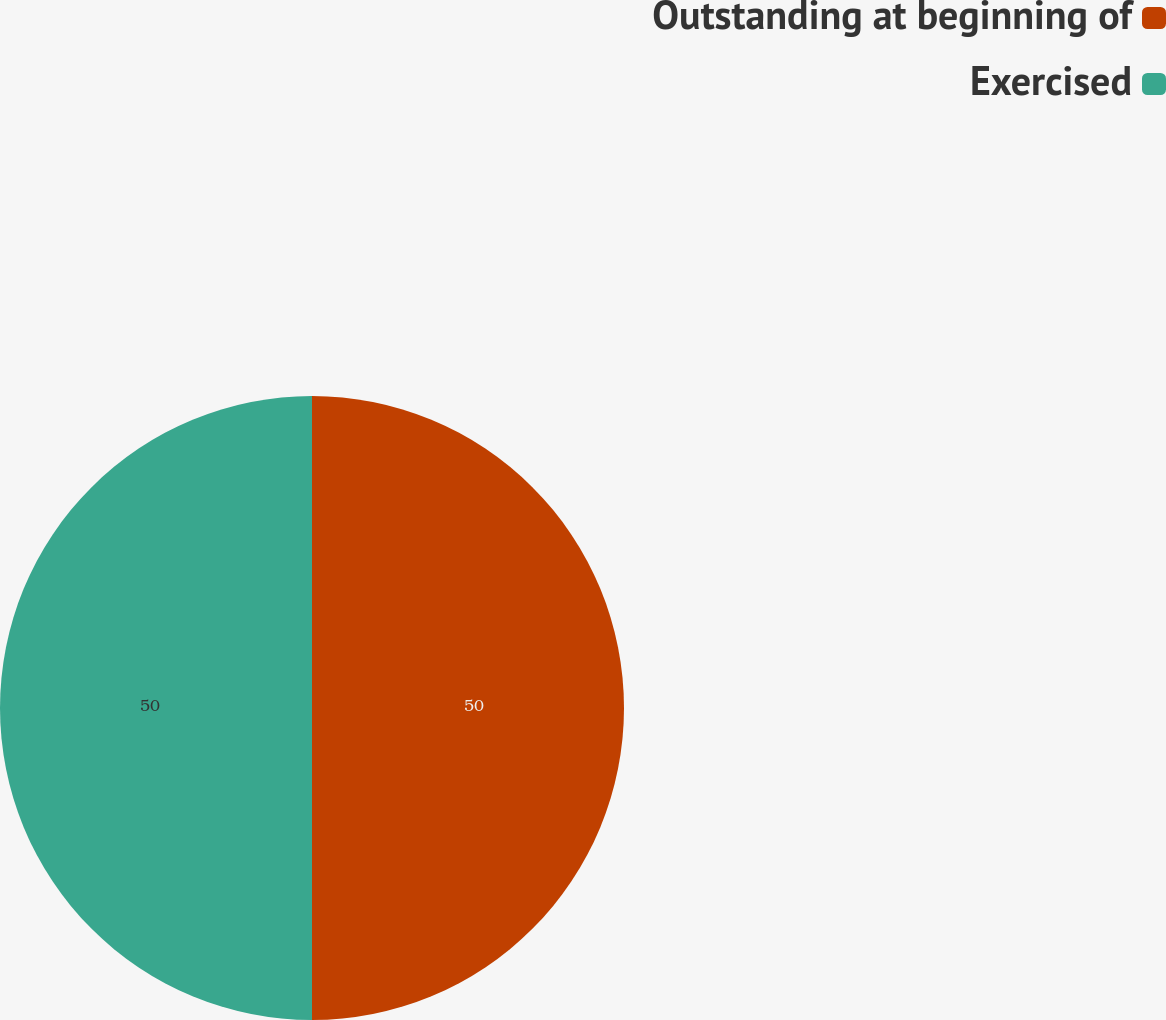Convert chart. <chart><loc_0><loc_0><loc_500><loc_500><pie_chart><fcel>Outstanding at beginning of<fcel>Exercised<nl><fcel>50.0%<fcel>50.0%<nl></chart> 